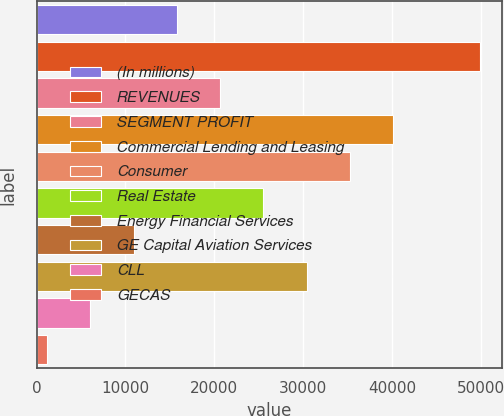Convert chart to OTSL. <chart><loc_0><loc_0><loc_500><loc_500><bar_chart><fcel>(In millions)<fcel>REVENUES<fcel>SEGMENT PROFIT<fcel>Commercial Lending and Leasing<fcel>Consumer<fcel>Real Estate<fcel>Energy Financial Services<fcel>GE Capital Aviation Services<fcel>CLL<fcel>GECAS<nl><fcel>15793.3<fcel>49856<fcel>20659.4<fcel>40123.8<fcel>35257.7<fcel>25525.5<fcel>10927.2<fcel>30391.6<fcel>6061.1<fcel>1195<nl></chart> 